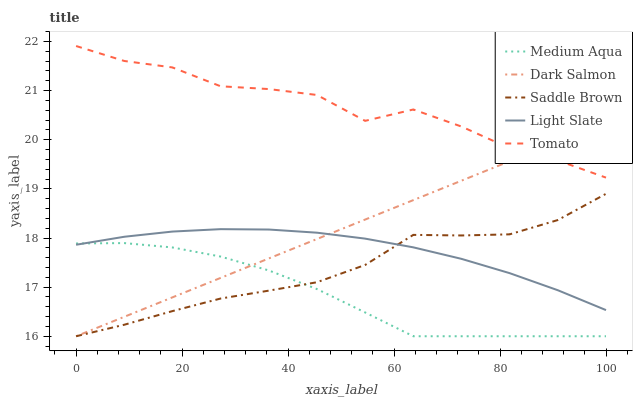Does Medium Aqua have the minimum area under the curve?
Answer yes or no. Yes. Does Tomato have the maximum area under the curve?
Answer yes or no. Yes. Does Tomato have the minimum area under the curve?
Answer yes or no. No. Does Medium Aqua have the maximum area under the curve?
Answer yes or no. No. Is Dark Salmon the smoothest?
Answer yes or no. Yes. Is Tomato the roughest?
Answer yes or no. Yes. Is Medium Aqua the smoothest?
Answer yes or no. No. Is Medium Aqua the roughest?
Answer yes or no. No. Does Medium Aqua have the lowest value?
Answer yes or no. Yes. Does Tomato have the lowest value?
Answer yes or no. No. Does Tomato have the highest value?
Answer yes or no. Yes. Does Medium Aqua have the highest value?
Answer yes or no. No. Is Light Slate less than Tomato?
Answer yes or no. Yes. Is Tomato greater than Medium Aqua?
Answer yes or no. Yes. Does Light Slate intersect Saddle Brown?
Answer yes or no. Yes. Is Light Slate less than Saddle Brown?
Answer yes or no. No. Is Light Slate greater than Saddle Brown?
Answer yes or no. No. Does Light Slate intersect Tomato?
Answer yes or no. No. 